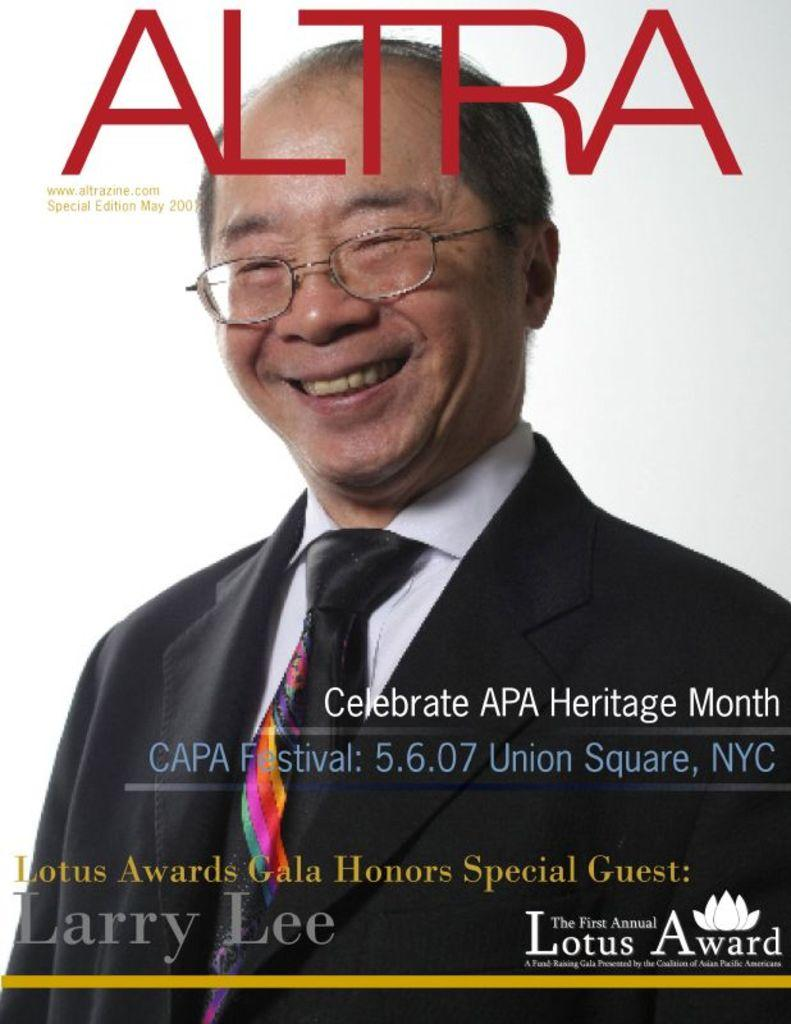What type of page is depicted in the image? The image appears to be a cover page. Can you describe the person in the image? There is a man in the image. What is written at the top of the image? There is text at the top of the image. What is written at the bottom of the image? There is text at the bottom of the image. What color is the background of the image? The background of the image is white. What type of holiday is being celebrated in the image? There is no indication of a holiday being celebrated in the image. What list of items can be seen in the image? There is no list of items present in the image. 